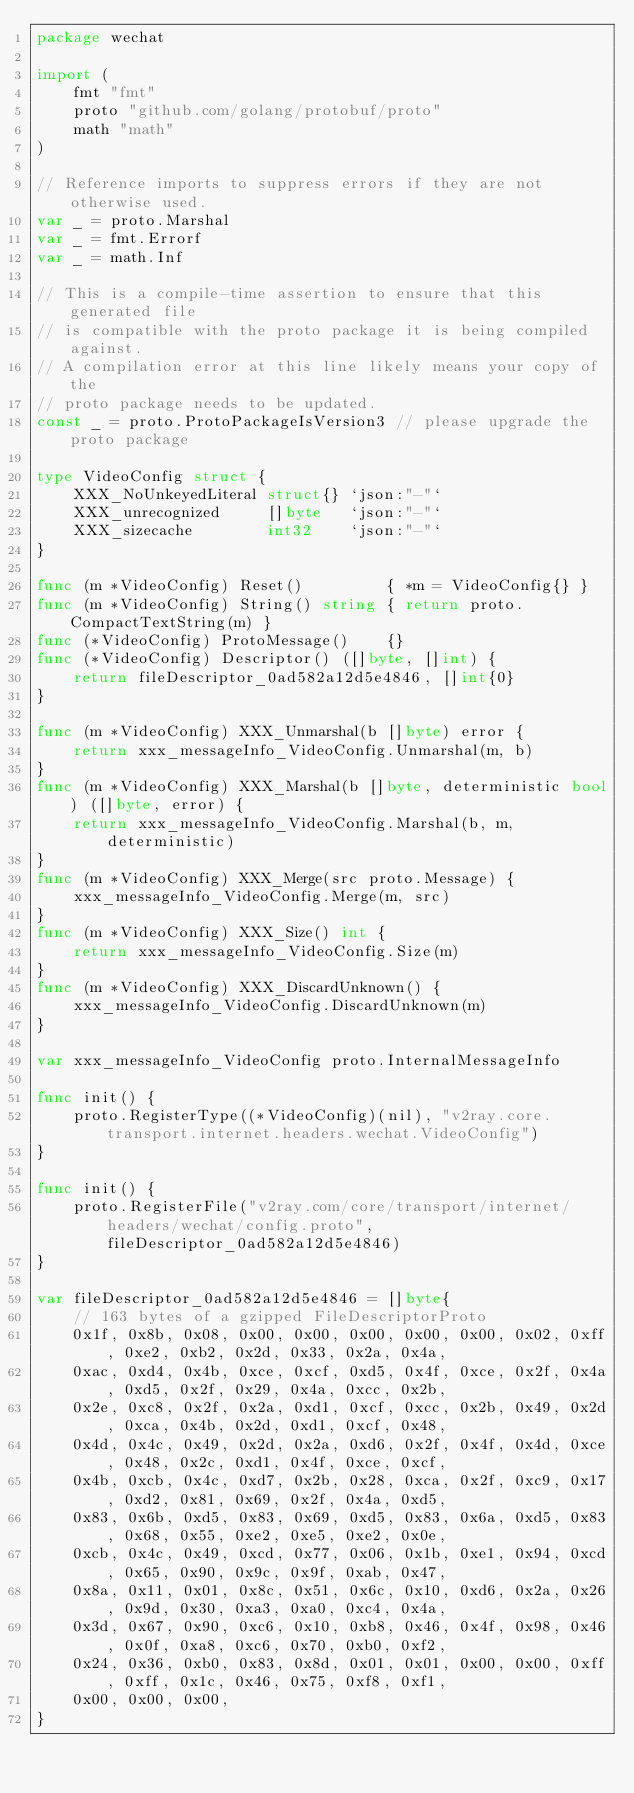<code> <loc_0><loc_0><loc_500><loc_500><_Go_>package wechat

import (
	fmt "fmt"
	proto "github.com/golang/protobuf/proto"
	math "math"
)

// Reference imports to suppress errors if they are not otherwise used.
var _ = proto.Marshal
var _ = fmt.Errorf
var _ = math.Inf

// This is a compile-time assertion to ensure that this generated file
// is compatible with the proto package it is being compiled against.
// A compilation error at this line likely means your copy of the
// proto package needs to be updated.
const _ = proto.ProtoPackageIsVersion3 // please upgrade the proto package

type VideoConfig struct {
	XXX_NoUnkeyedLiteral struct{} `json:"-"`
	XXX_unrecognized     []byte   `json:"-"`
	XXX_sizecache        int32    `json:"-"`
}

func (m *VideoConfig) Reset()         { *m = VideoConfig{} }
func (m *VideoConfig) String() string { return proto.CompactTextString(m) }
func (*VideoConfig) ProtoMessage()    {}
func (*VideoConfig) Descriptor() ([]byte, []int) {
	return fileDescriptor_0ad582a12d5e4846, []int{0}
}

func (m *VideoConfig) XXX_Unmarshal(b []byte) error {
	return xxx_messageInfo_VideoConfig.Unmarshal(m, b)
}
func (m *VideoConfig) XXX_Marshal(b []byte, deterministic bool) ([]byte, error) {
	return xxx_messageInfo_VideoConfig.Marshal(b, m, deterministic)
}
func (m *VideoConfig) XXX_Merge(src proto.Message) {
	xxx_messageInfo_VideoConfig.Merge(m, src)
}
func (m *VideoConfig) XXX_Size() int {
	return xxx_messageInfo_VideoConfig.Size(m)
}
func (m *VideoConfig) XXX_DiscardUnknown() {
	xxx_messageInfo_VideoConfig.DiscardUnknown(m)
}

var xxx_messageInfo_VideoConfig proto.InternalMessageInfo

func init() {
	proto.RegisterType((*VideoConfig)(nil), "v2ray.core.transport.internet.headers.wechat.VideoConfig")
}

func init() {
	proto.RegisterFile("v2ray.com/core/transport/internet/headers/wechat/config.proto", fileDescriptor_0ad582a12d5e4846)
}

var fileDescriptor_0ad582a12d5e4846 = []byte{
	// 163 bytes of a gzipped FileDescriptorProto
	0x1f, 0x8b, 0x08, 0x00, 0x00, 0x00, 0x00, 0x00, 0x02, 0xff, 0xe2, 0xb2, 0x2d, 0x33, 0x2a, 0x4a,
	0xac, 0xd4, 0x4b, 0xce, 0xcf, 0xd5, 0x4f, 0xce, 0x2f, 0x4a, 0xd5, 0x2f, 0x29, 0x4a, 0xcc, 0x2b,
	0x2e, 0xc8, 0x2f, 0x2a, 0xd1, 0xcf, 0xcc, 0x2b, 0x49, 0x2d, 0xca, 0x4b, 0x2d, 0xd1, 0xcf, 0x48,
	0x4d, 0x4c, 0x49, 0x2d, 0x2a, 0xd6, 0x2f, 0x4f, 0x4d, 0xce, 0x48, 0x2c, 0xd1, 0x4f, 0xce, 0xcf,
	0x4b, 0xcb, 0x4c, 0xd7, 0x2b, 0x28, 0xca, 0x2f, 0xc9, 0x17, 0xd2, 0x81, 0x69, 0x2f, 0x4a, 0xd5,
	0x83, 0x6b, 0xd5, 0x83, 0x69, 0xd5, 0x83, 0x6a, 0xd5, 0x83, 0x68, 0x55, 0xe2, 0xe5, 0xe2, 0x0e,
	0xcb, 0x4c, 0x49, 0xcd, 0x77, 0x06, 0x1b, 0xe1, 0x94, 0xcd, 0x65, 0x90, 0x9c, 0x9f, 0xab, 0x47,
	0x8a, 0x11, 0x01, 0x8c, 0x51, 0x6c, 0x10, 0xd6, 0x2a, 0x26, 0x9d, 0x30, 0xa3, 0xa0, 0xc4, 0x4a,
	0x3d, 0x67, 0x90, 0xc6, 0x10, 0xb8, 0x46, 0x4f, 0x98, 0x46, 0x0f, 0xa8, 0xc6, 0x70, 0xb0, 0xf2,
	0x24, 0x36, 0xb0, 0x83, 0x8d, 0x01, 0x01, 0x00, 0x00, 0xff, 0xff, 0x1c, 0x46, 0x75, 0xf8, 0xf1,
	0x00, 0x00, 0x00,
}
</code> 